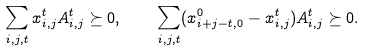Convert formula to latex. <formula><loc_0><loc_0><loc_500><loc_500>\sum _ { i , j , t } x _ { i , j } ^ { t } A _ { i , j } ^ { t } \succeq 0 , \quad \sum _ { i , j , t } ( x _ { i + j - t , 0 } ^ { 0 } - x _ { i , j } ^ { t } ) A _ { i , j } ^ { t } \succeq 0 .</formula> 